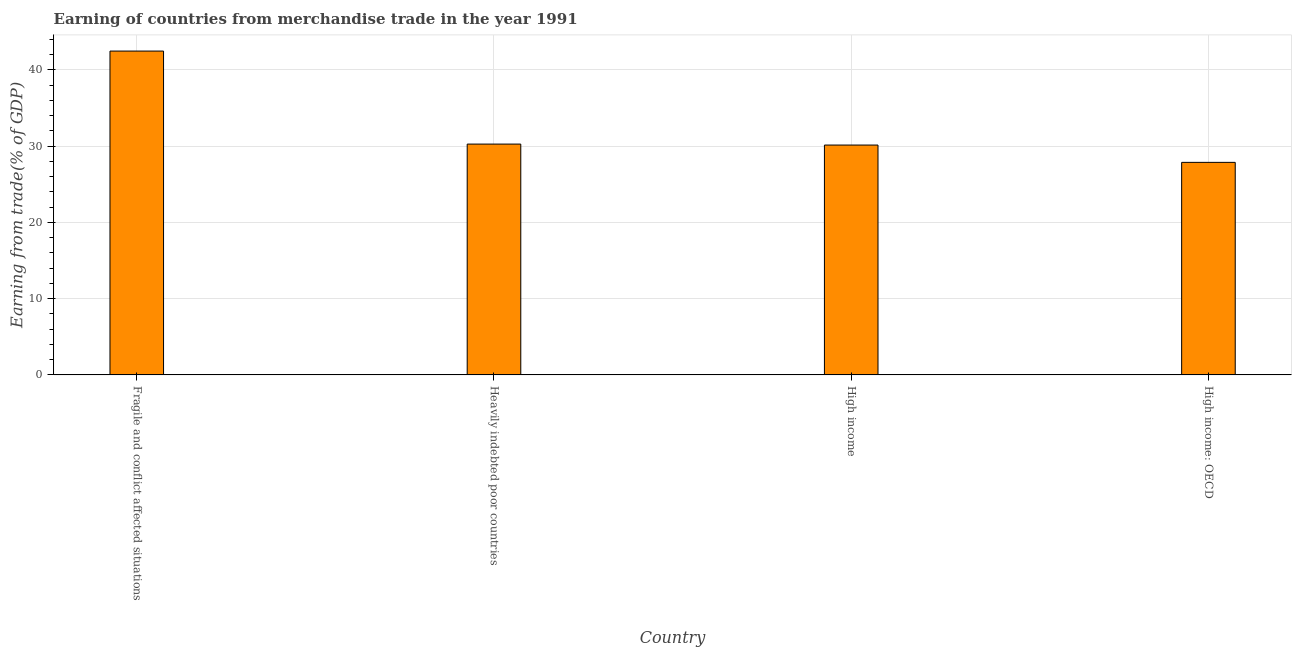Does the graph contain grids?
Make the answer very short. Yes. What is the title of the graph?
Give a very brief answer. Earning of countries from merchandise trade in the year 1991. What is the label or title of the Y-axis?
Your answer should be very brief. Earning from trade(% of GDP). What is the earning from merchandise trade in High income?
Offer a very short reply. 30.14. Across all countries, what is the maximum earning from merchandise trade?
Ensure brevity in your answer.  42.46. Across all countries, what is the minimum earning from merchandise trade?
Your answer should be very brief. 27.86. In which country was the earning from merchandise trade maximum?
Offer a terse response. Fragile and conflict affected situations. In which country was the earning from merchandise trade minimum?
Your response must be concise. High income: OECD. What is the sum of the earning from merchandise trade?
Offer a terse response. 130.72. What is the difference between the earning from merchandise trade in Fragile and conflict affected situations and High income?
Provide a short and direct response. 12.32. What is the average earning from merchandise trade per country?
Your answer should be compact. 32.68. What is the median earning from merchandise trade?
Keep it short and to the point. 30.2. What is the ratio of the earning from merchandise trade in High income to that in High income: OECD?
Provide a short and direct response. 1.08. Is the difference between the earning from merchandise trade in Fragile and conflict affected situations and High income greater than the difference between any two countries?
Provide a short and direct response. No. What is the difference between the highest and the second highest earning from merchandise trade?
Your answer should be compact. 12.2. Is the sum of the earning from merchandise trade in Heavily indebted poor countries and High income greater than the maximum earning from merchandise trade across all countries?
Your response must be concise. Yes. What is the difference between the highest and the lowest earning from merchandise trade?
Ensure brevity in your answer.  14.59. How many bars are there?
Offer a terse response. 4. Are all the bars in the graph horizontal?
Provide a short and direct response. No. Are the values on the major ticks of Y-axis written in scientific E-notation?
Provide a short and direct response. No. What is the Earning from trade(% of GDP) in Fragile and conflict affected situations?
Make the answer very short. 42.46. What is the Earning from trade(% of GDP) in Heavily indebted poor countries?
Your answer should be compact. 30.26. What is the Earning from trade(% of GDP) in High income?
Keep it short and to the point. 30.14. What is the Earning from trade(% of GDP) of High income: OECD?
Your response must be concise. 27.86. What is the difference between the Earning from trade(% of GDP) in Fragile and conflict affected situations and Heavily indebted poor countries?
Ensure brevity in your answer.  12.19. What is the difference between the Earning from trade(% of GDP) in Fragile and conflict affected situations and High income?
Your answer should be very brief. 12.32. What is the difference between the Earning from trade(% of GDP) in Fragile and conflict affected situations and High income: OECD?
Offer a very short reply. 14.59. What is the difference between the Earning from trade(% of GDP) in Heavily indebted poor countries and High income?
Provide a succinct answer. 0.13. What is the difference between the Earning from trade(% of GDP) in Heavily indebted poor countries and High income: OECD?
Ensure brevity in your answer.  2.4. What is the difference between the Earning from trade(% of GDP) in High income and High income: OECD?
Your answer should be compact. 2.27. What is the ratio of the Earning from trade(% of GDP) in Fragile and conflict affected situations to that in Heavily indebted poor countries?
Provide a short and direct response. 1.4. What is the ratio of the Earning from trade(% of GDP) in Fragile and conflict affected situations to that in High income?
Your answer should be very brief. 1.41. What is the ratio of the Earning from trade(% of GDP) in Fragile and conflict affected situations to that in High income: OECD?
Give a very brief answer. 1.52. What is the ratio of the Earning from trade(% of GDP) in Heavily indebted poor countries to that in High income: OECD?
Offer a terse response. 1.09. What is the ratio of the Earning from trade(% of GDP) in High income to that in High income: OECD?
Provide a short and direct response. 1.08. 